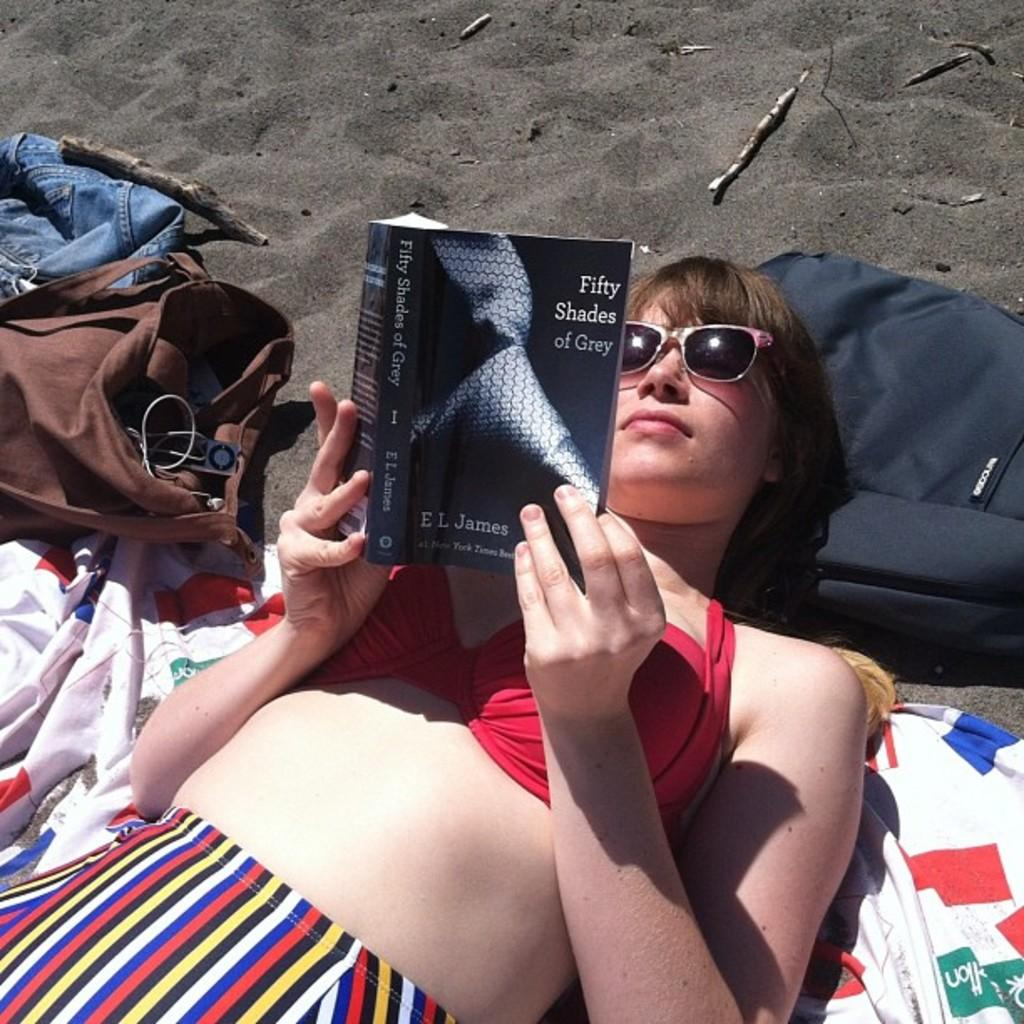Who is the main subject in the picture? There is a woman in the picture. What is the woman doing in the image? The woman is lying down. What is the woman holding in the image? The woman is holding a book. What can be seen on the book? There is text on the book. What else is visible at the bottom of the image? There are bags at the bottom of the image. What type of surface can be seen in the image? There are clothes on the sand. What is the distance between the woman and the learning opportunity in the image? There is no specific learning opportunity mentioned in the image, so it is not possible to determine the distance between the woman and it. 